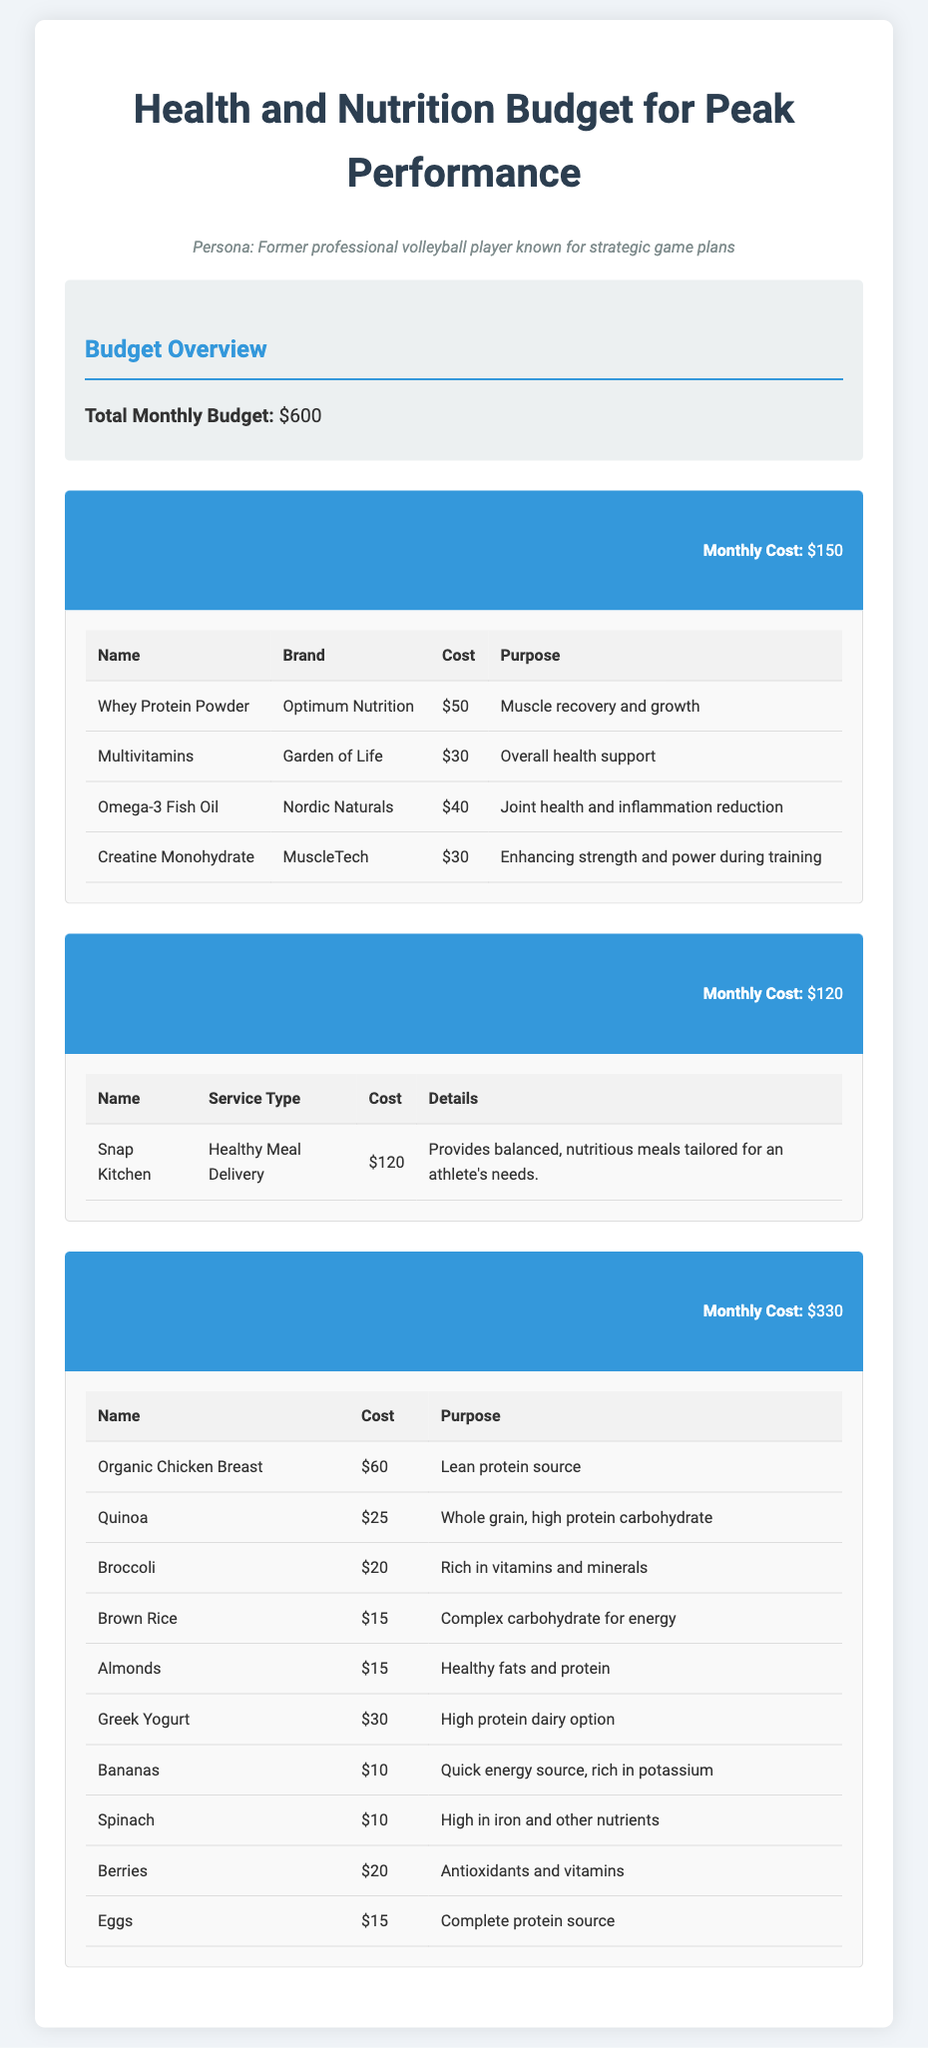What is the total monthly budget? The total monthly budget is stated in the budget overview section of the document.
Answer: $600 How much is spent on supplements monthly? The monthly cost for supplements is presented in the supplements category header.
Answer: $150 What service does Snap Kitchen provide? The details for Snap Kitchen in the meal planning services section clarify what it provides.
Answer: Healthy Meal Delivery Which brand is associated with Omega-3 Fish Oil? The brand for Omega-3 Fish Oil is listed in the supplements table.
Answer: Nordic Naturals What is the cost of Greek Yogurt? The cost of Greek Yogurt can be found in the grocery bills table.
Answer: $30 What is the purpose of using Creatine Monohydrate? The purpose of Creatine Monohydrate is explained in the supplements table.
Answer: Enhancing strength and power during training How many items are listed under grocery bills? The total number of items can be counted in the grocery bills table.
Answer: 10 What is the total cost of grocery bills? The monthly cost for grocery bills is mentioned in the category header of grocery bills.
Answer: $330 Which supplement costs the most? By comparing the prices in the supplements table, we determine the most expensive item.
Answer: Whey Protein Powder 